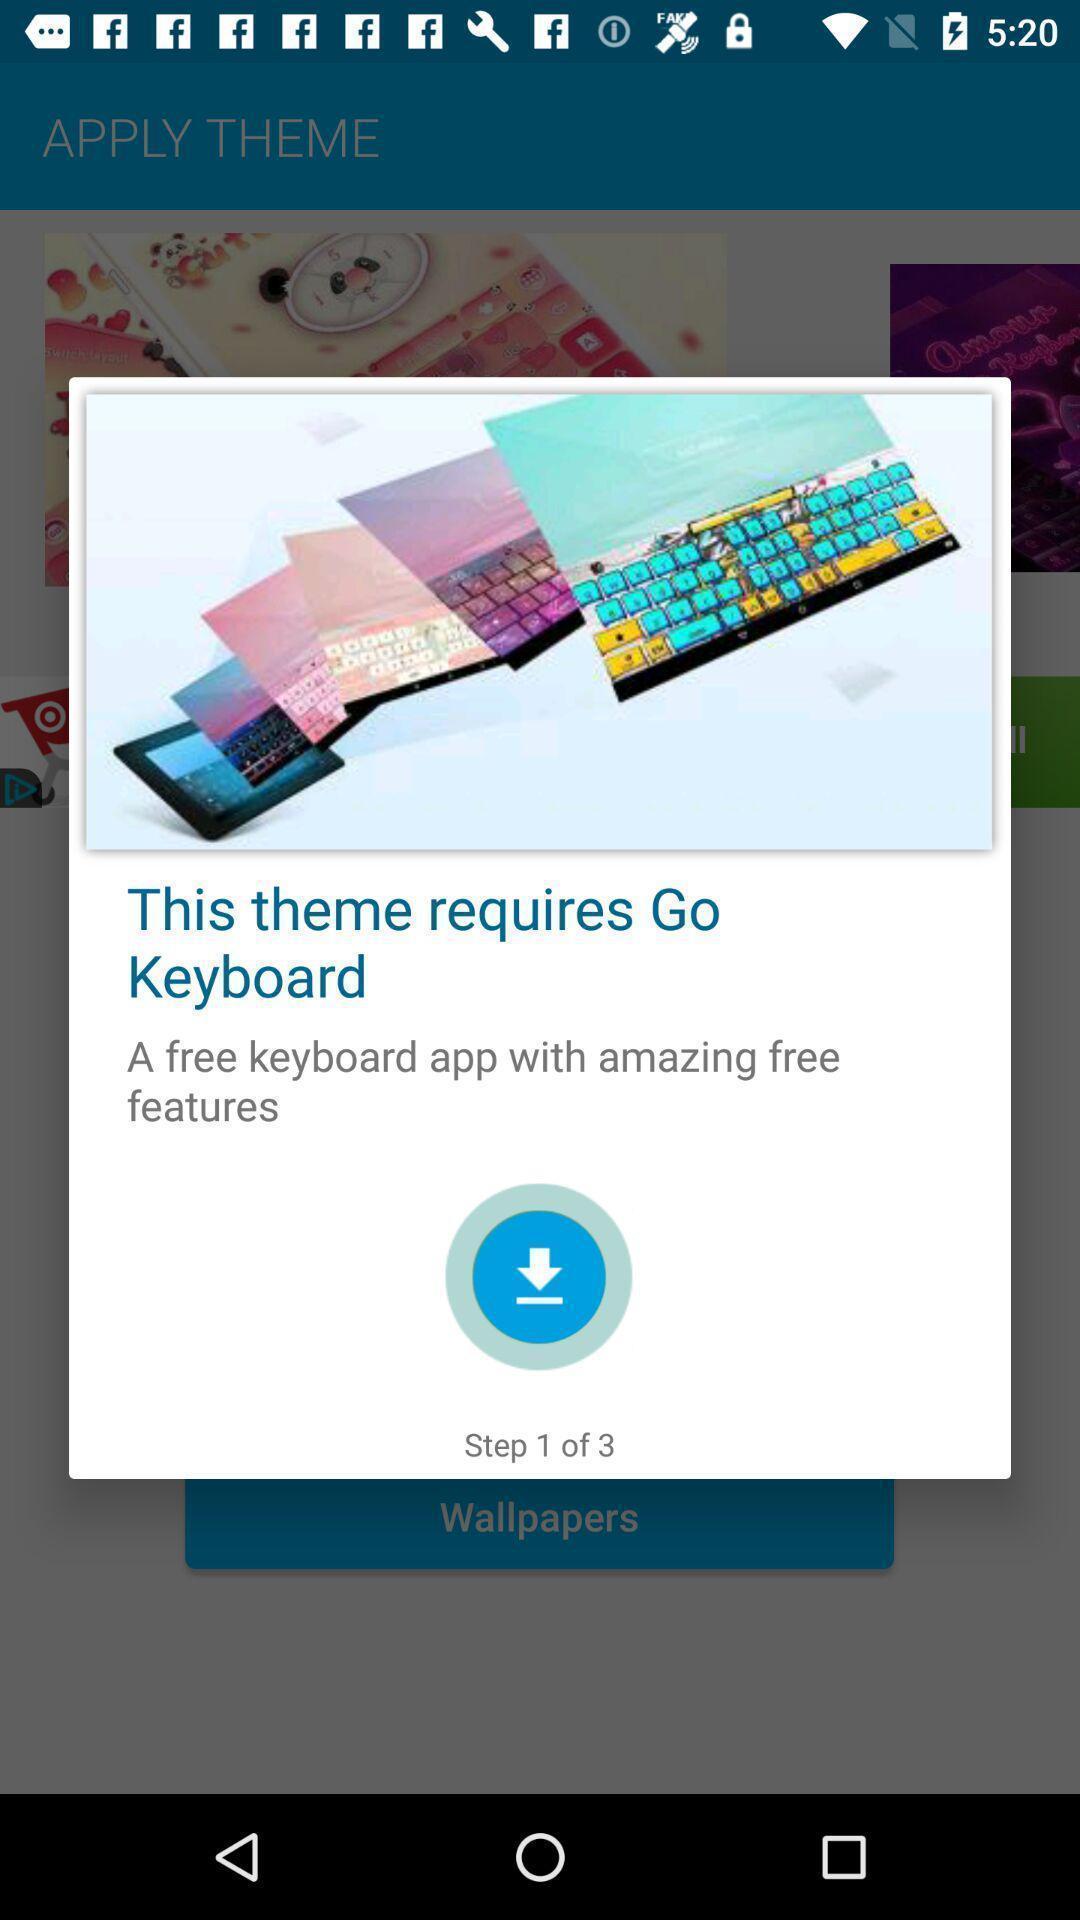Describe the visual elements of this screenshot. Pop-up showing the themes with keyboard app. 